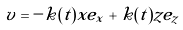Convert formula to latex. <formula><loc_0><loc_0><loc_500><loc_500>v = - k ( t ) x e _ { x } + k ( t ) z e _ { z }</formula> 